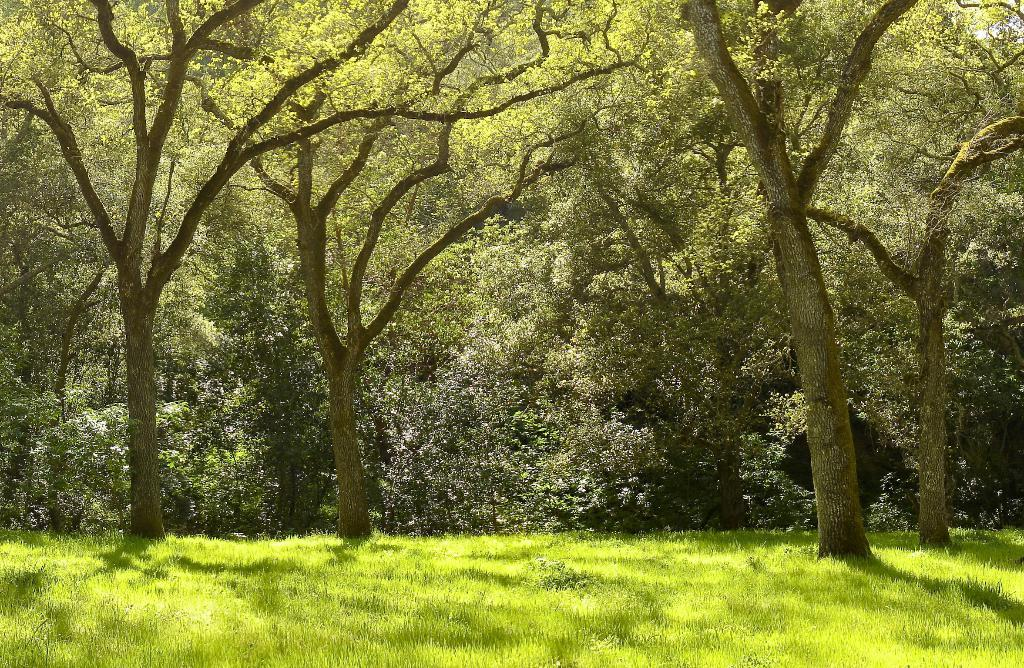What type of vegetation is predominant in the image? There are many trees in the image. What is the color of the grass at the bottom of the image? The grass at the bottom of the image is green. Can you describe the setting of the image? The image appears to be taken in a forest. How many bananas can be seen hanging from the trees in the image? There are no bananas visible in the image; it features trees and green grass. What type of haircut does the tree on the left have in the image? Trees do not have haircuts, as they are plants and not humans or animals. 